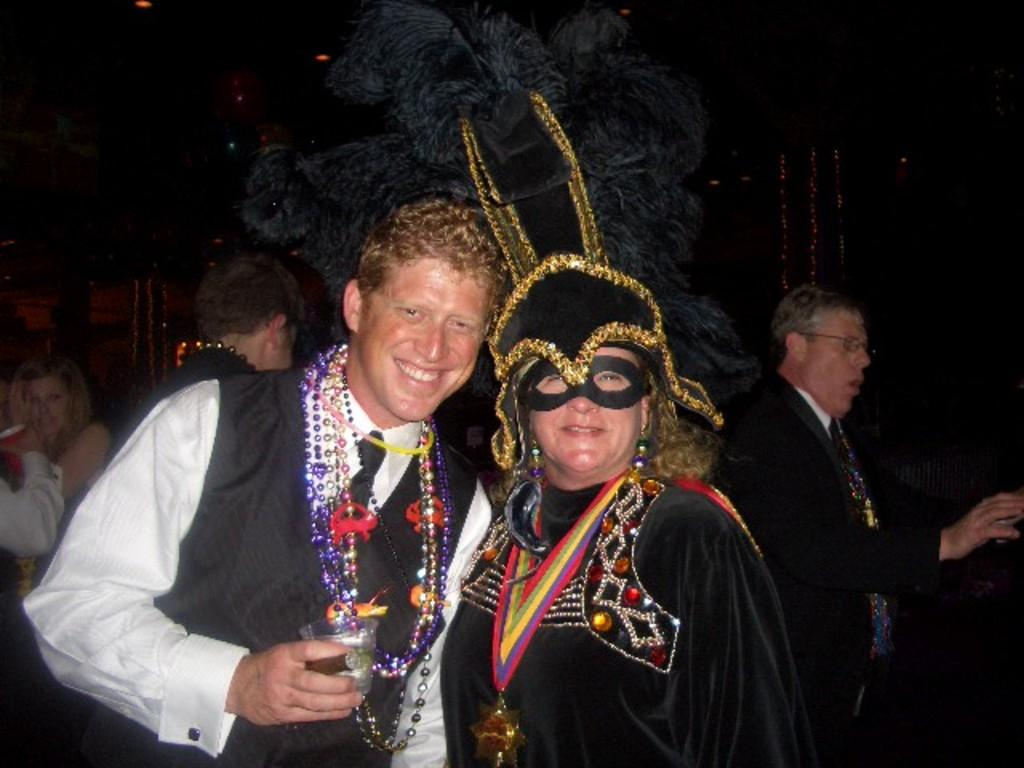How many people are in the image? There is a group of people in the image. What are the people wearing? The people are wearing clothes. Can you describe any specific accessory or item one person is wearing? One person is wearing a mask. What type of vein is visible on the person's face in the image? There is no visible vein on the person's face in the image. Can you describe the person's laugh in the image? There is no laughter depicted in the image; the people are not shown expressing any emotions. 